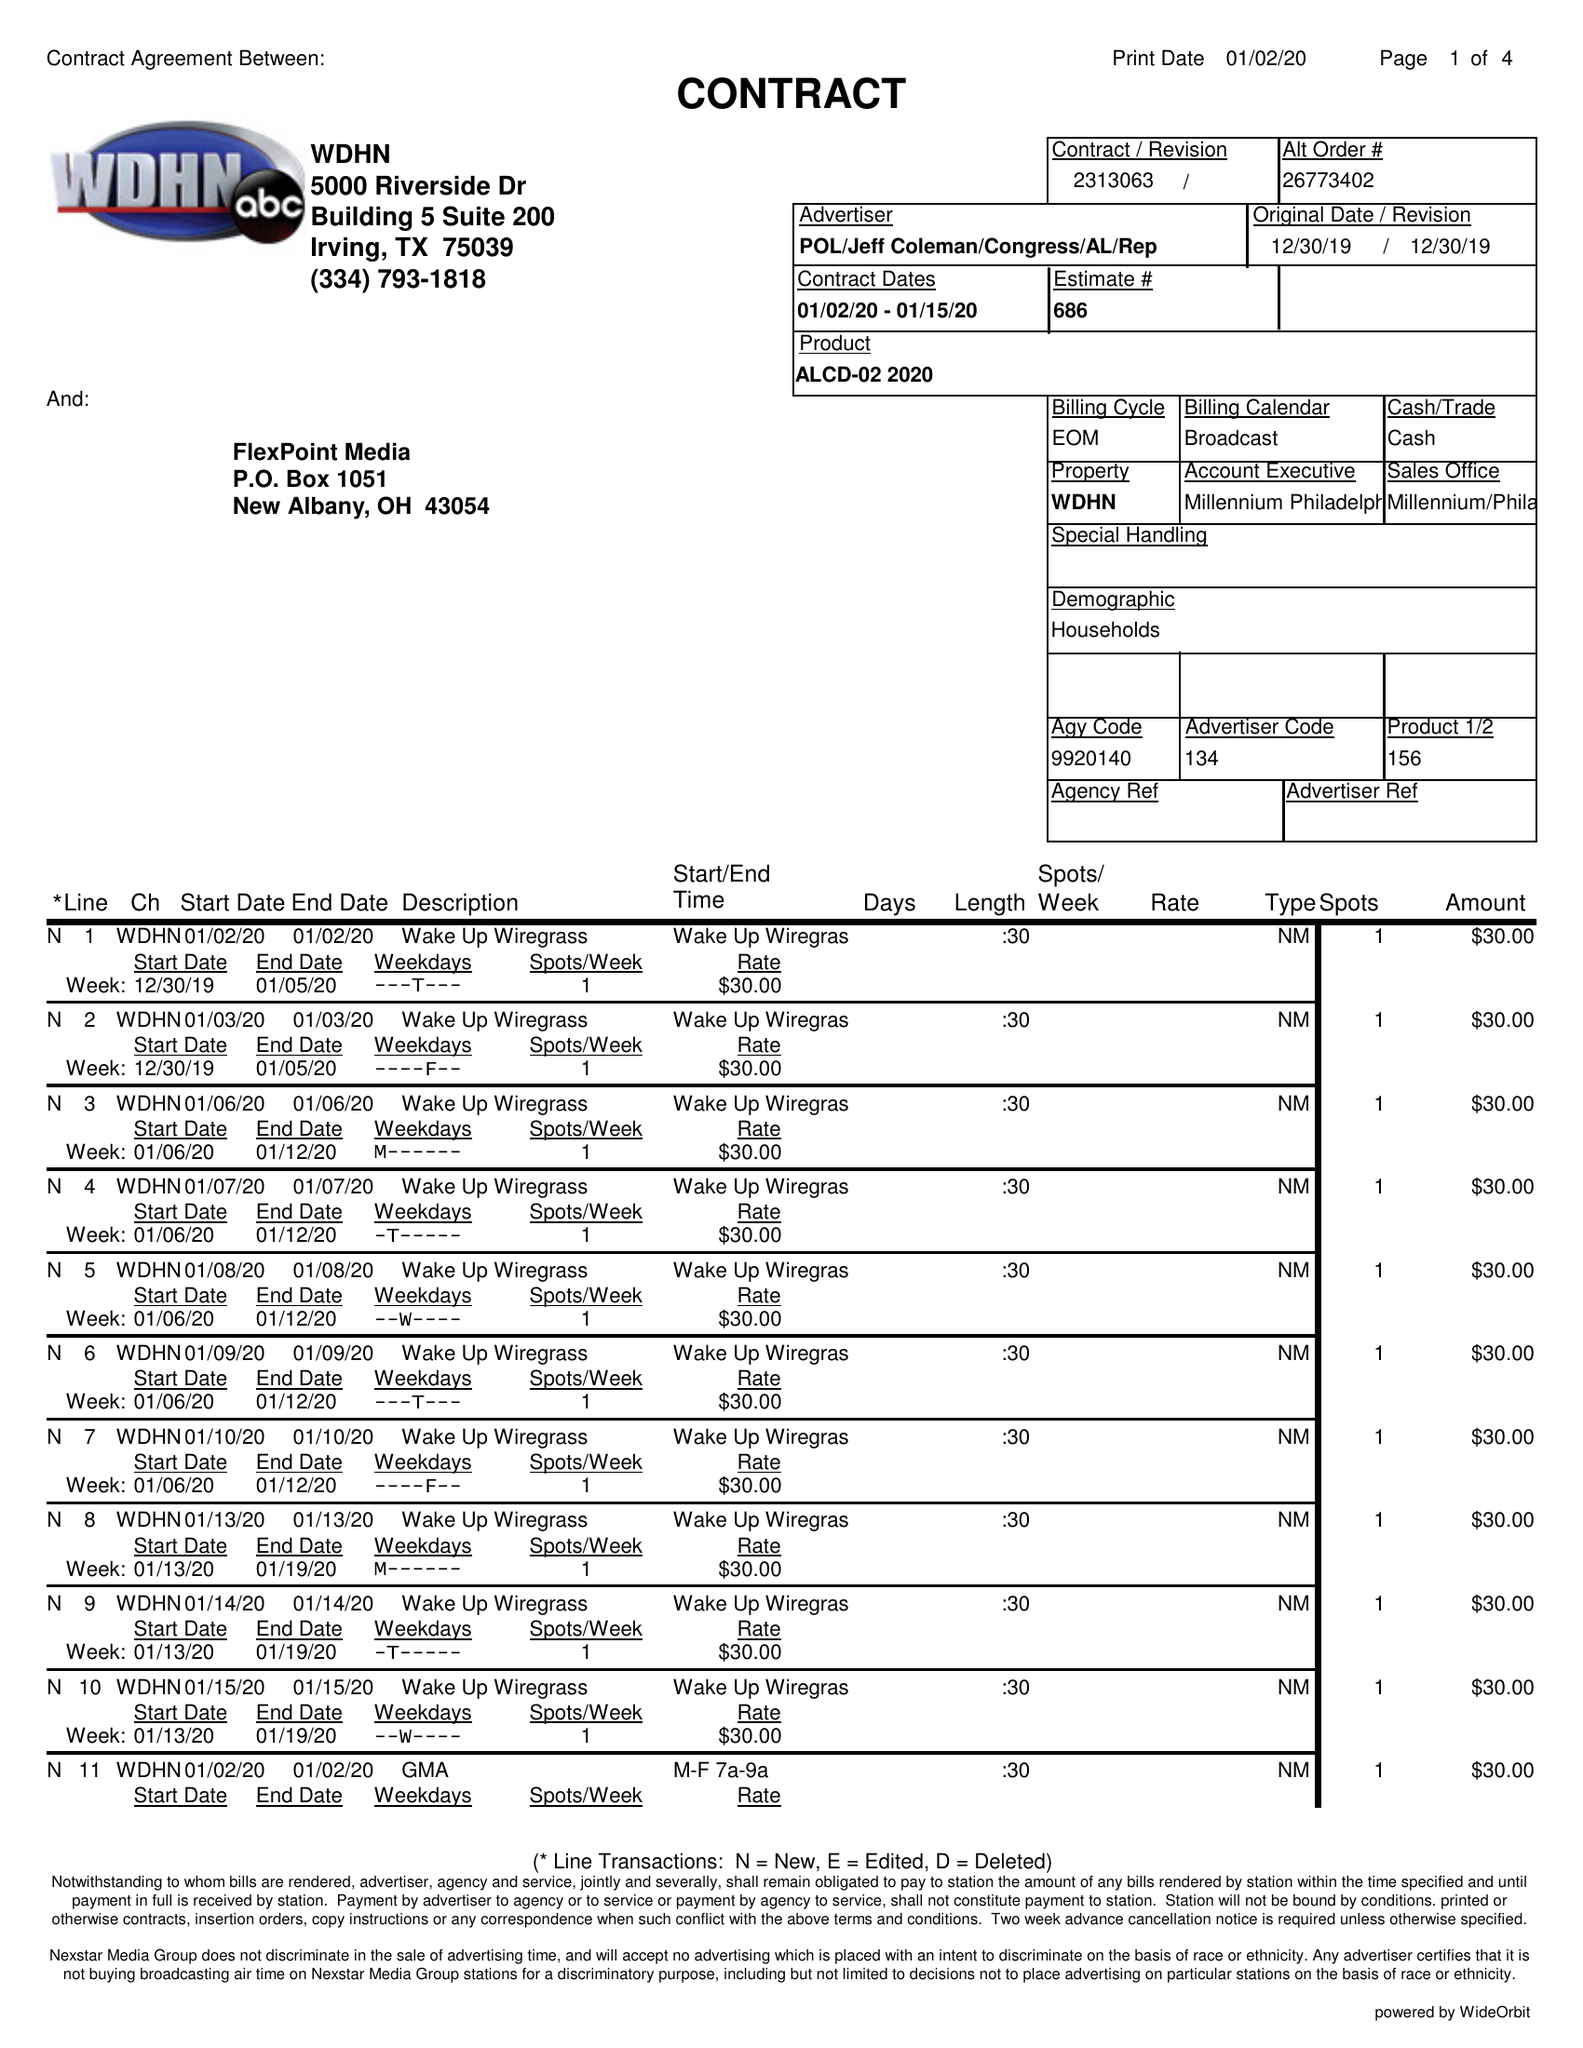What is the value for the flight_from?
Answer the question using a single word or phrase. 01/02/20 